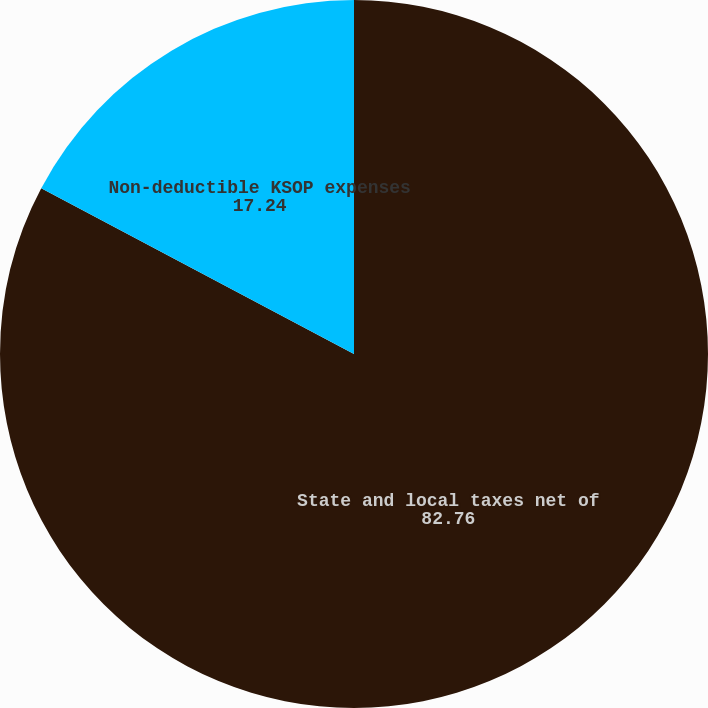Convert chart to OTSL. <chart><loc_0><loc_0><loc_500><loc_500><pie_chart><fcel>State and local taxes net of<fcel>Non-deductible KSOP expenses<nl><fcel>82.76%<fcel>17.24%<nl></chart> 